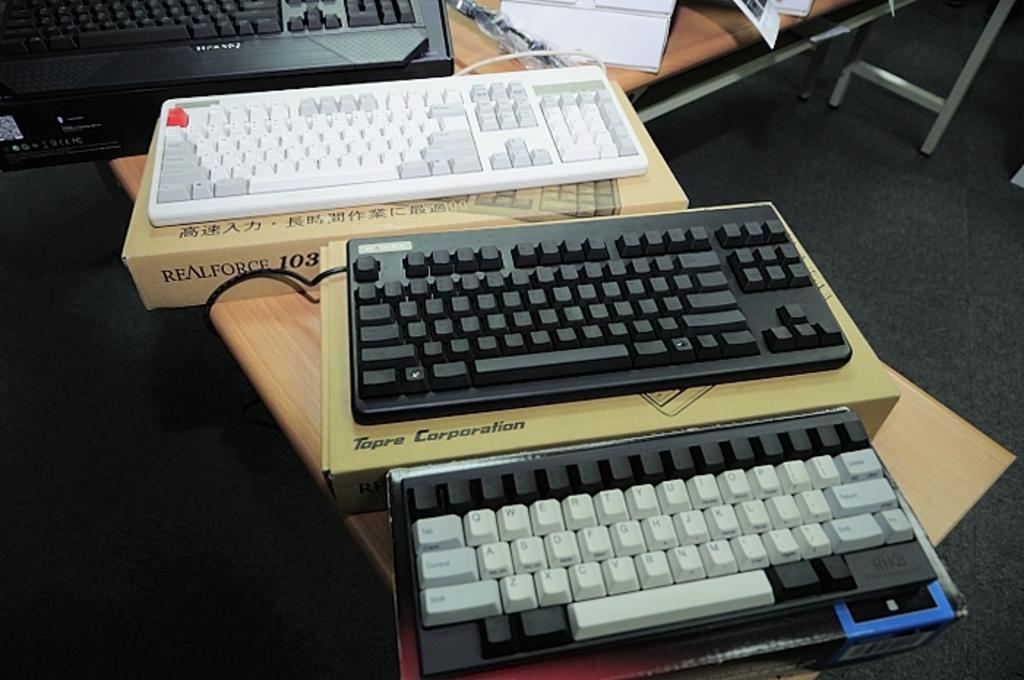What brand is this?
Offer a very short reply. Topre corporation. 